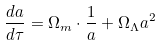<formula> <loc_0><loc_0><loc_500><loc_500>\frac { d a } { d \tau } = \Omega _ { m } \cdot \frac { 1 } { a } + \Omega _ { \Lambda } a ^ { 2 }</formula> 